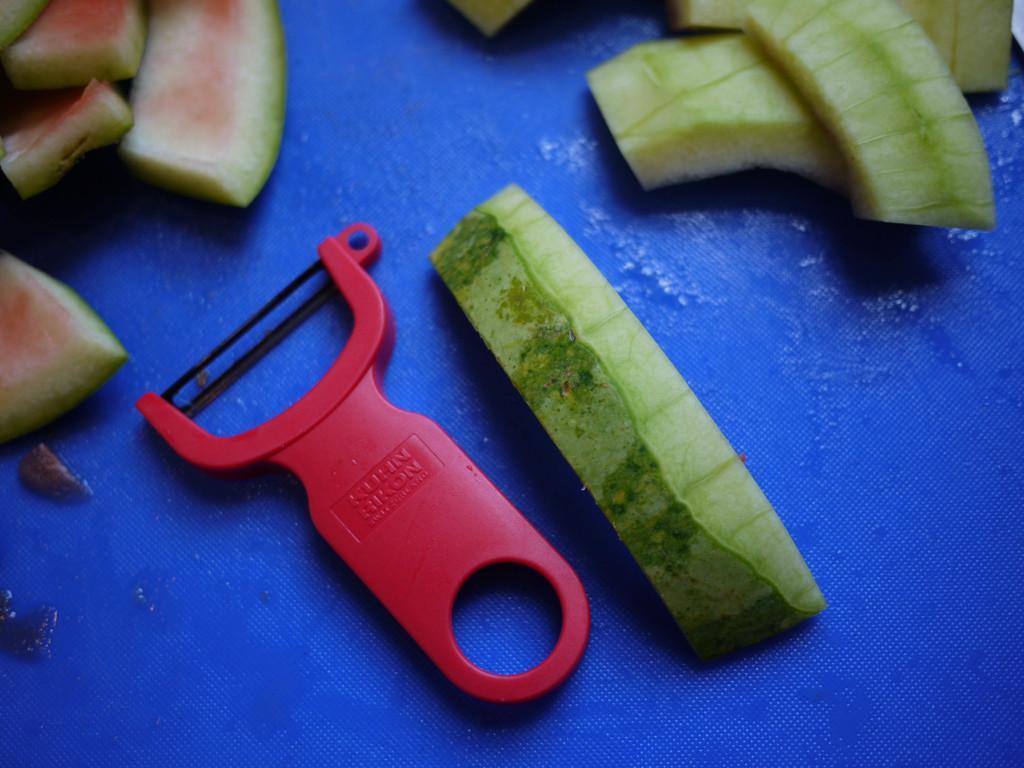Can you describe this image briefly? In this picture we can see a peeler and peels of watermelon on the platform. 